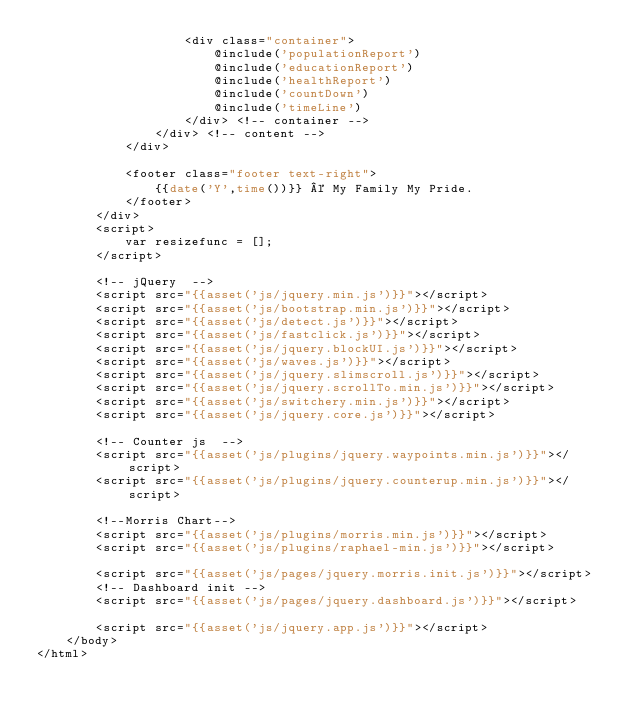Convert code to text. <code><loc_0><loc_0><loc_500><loc_500><_PHP_>                    <div class="container">
                        @include('populationReport')
                        @include('educationReport')
                        @include('healthReport')
                        @include('countDown')
                        @include('timeLine')
                    </div> <!-- container -->
                </div> <!-- content -->
            </div>
            
            <footer class="footer text-right">
                {{date('Y',time())}} © My Family My Pride.
            </footer>
        </div>
        <script>
            var resizefunc = [];
        </script>

        <!-- jQuery  -->
        <script src="{{asset('js/jquery.min.js')}}"></script>
        <script src="{{asset('js/bootstrap.min.js')}}"></script>
        <script src="{{asset('js/detect.js')}}"></script>
        <script src="{{asset('js/fastclick.js')}}"></script>
        <script src="{{asset('js/jquery.blockUI.js')}}"></script>
        <script src="{{asset('js/waves.js')}}"></script>
        <script src="{{asset('js/jquery.slimscroll.js')}}"></script>
        <script src="{{asset('js/jquery.scrollTo.min.js')}}"></script>
        <script src="{{asset('js/switchery.min.js')}}"></script>
        <script src="{{asset('js/jquery.core.js')}}"></script>

        <!-- Counter js  -->
        <script src="{{asset('js/plugins/jquery.waypoints.min.js')}}"></script>
        <script src="{{asset('js/plugins/jquery.counterup.min.js')}}"></script>

        <!--Morris Chart-->
		<script src="{{asset('js/plugins/morris.min.js')}}"></script>
		<script src="{{asset('js/plugins/raphael-min.js')}}"></script>
        
		<script src="{{asset('js/pages/jquery.morris.init.js')}}"></script>
        <!-- Dashboard init -->
        <script src="{{asset('js/pages/jquery.dashboard.js')}}"></script>

        <script src="{{asset('js/jquery.app.js')}}"></script>
    </body>
</html></code> 